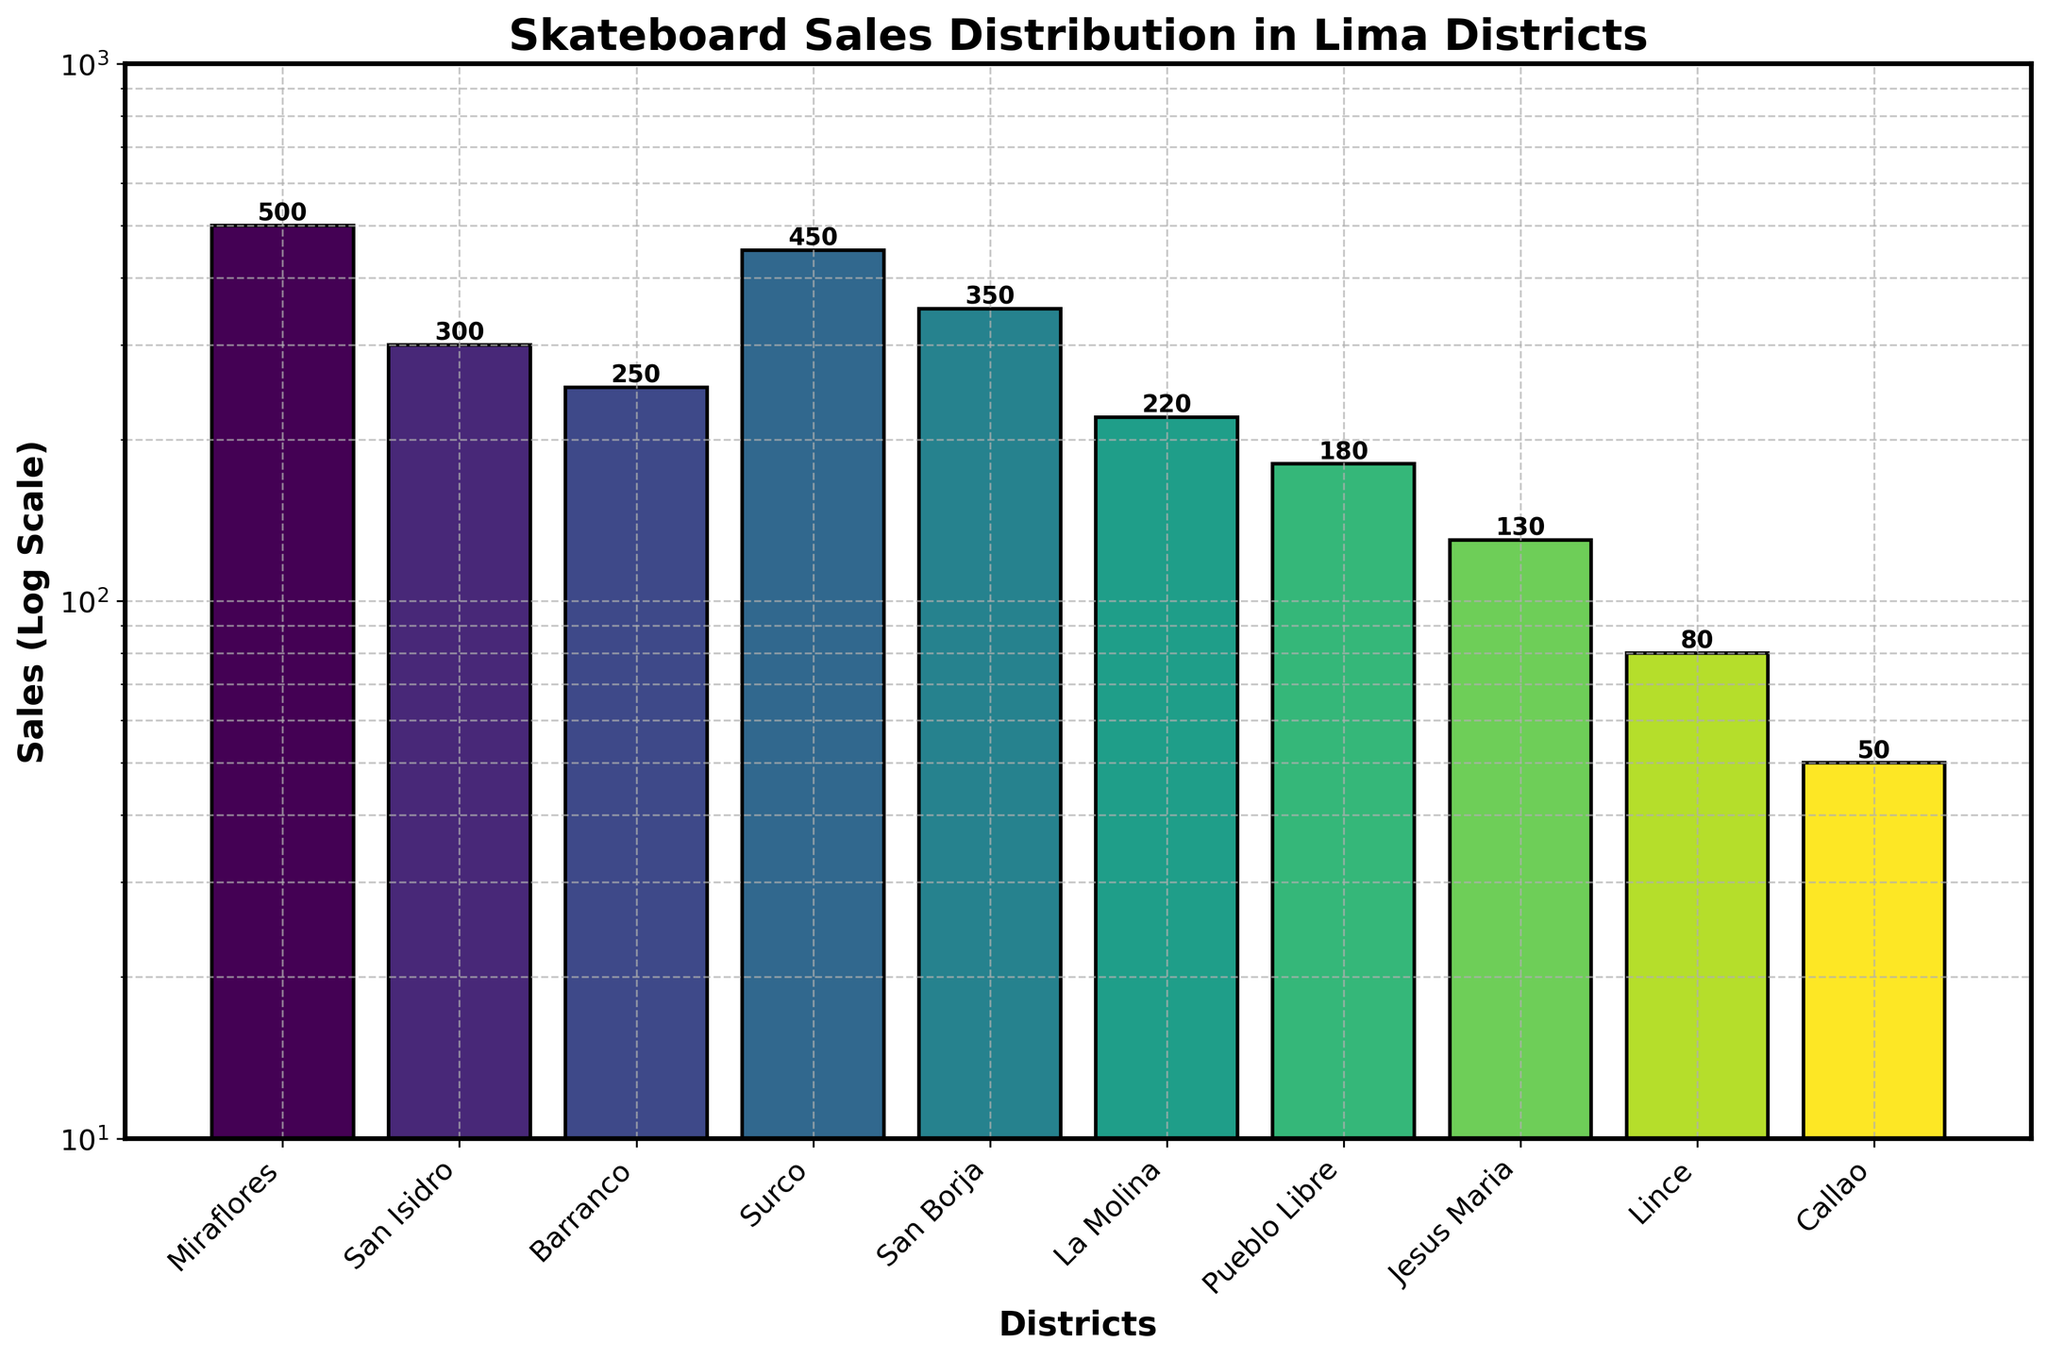What's the title of the figure? The title of the figure is typically located at the top of the chart, often in a bold and larger font. In this figure, the title reads "Skateboard Sales Distribution in Lima Districts".
Answer: Skateboard Sales Distribution in Lima Districts What is the range of the y-axis (Sales) on a log scale? The y-axis in the log scale indicates the range of values for skateboard sales. According to the figure, the range for the sales starts at 10 and ends at 1000.
Answer: 10 to 1000 Which district has the highest skateboard sales? By observing the height of the bars, we see the tallest bar represents Miraflores. This indicates that Miraflores has the highest skateboard sales among the listed districts.
Answer: Miraflores How much higher are the skateboard sales in Miraflores compared to Callao? First, note the sales in Miraflores (500) and Callao (50). The difference in sales is calculated as 500 - 50, resulting in 450.
Answer: 450 Which district has the second lowest skateboard sales? Comparing the heights of the bars representing each district, Callao has the lowest sales (50) and Lince has the second lowest with 80.
Answer: Lince What is the sum of skateboard sales in La Molina and San Borja? From the figure, La Molina has 220 sales and San Borja has 350 sales. Adding these together gives 220 + 350 = 570.
Answer: 570 List the districts with sales above 400. Observing the bars and their corresponding values, the districts with sales above 400 are Miraflores (500) and Surco (450).
Answer: Miraflores, Surco What is the average sales for Barranco, Surco, and San Borja? The sales figures for Barranco, Surco, and San Borja are 250, 450, and 350 respectively. The average is calculated as (250 + 450 + 350) / 3, which equals 1050 / 3 = 350.
Answer: 350 How do the skateboard sales in San Isidro and Jesus Maria compare? San Isidro has 300 sales and Jesus Maria has 130 sales. Since 300 is greater than 130, San Isidro has higher sales than Jesus Maria.
Answer: San Isidro has higher sales What percentage of total sales do San Isidro's sales represent? First, sum all sales: 500 + 300 + 250 + 450 + 350 + 220 + 180 + 130 + 80 + 50 = 2510. Then, find the percentage for San Isidro's 300 sales: (300 / 2510) * 100 ≈ 11.95%.
Answer: Approximately 11.95% 